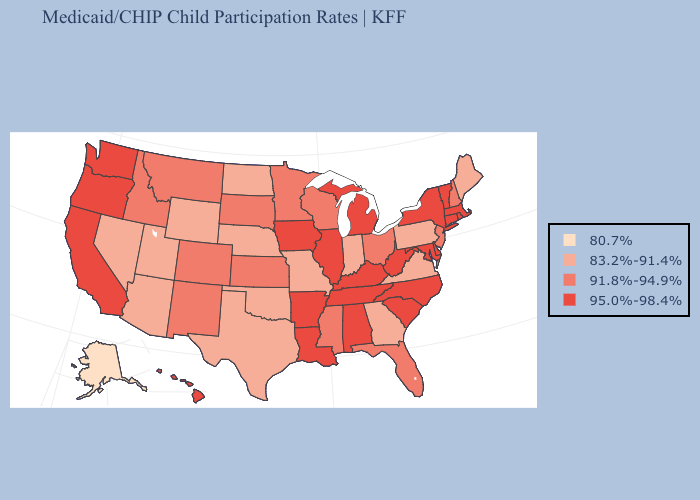What is the lowest value in states that border North Carolina?
Write a very short answer. 83.2%-91.4%. Does Vermont have the lowest value in the Northeast?
Give a very brief answer. No. Does New Mexico have a lower value than Pennsylvania?
Short answer required. No. Does Missouri have a higher value than Alaska?
Keep it brief. Yes. What is the value of Utah?
Be succinct. 83.2%-91.4%. What is the lowest value in states that border Georgia?
Write a very short answer. 91.8%-94.9%. Among the states that border South Carolina , which have the lowest value?
Short answer required. Georgia. What is the lowest value in states that border Delaware?
Write a very short answer. 83.2%-91.4%. Among the states that border Georgia , which have the lowest value?
Quick response, please. Florida. Which states hav the highest value in the MidWest?
Short answer required. Illinois, Iowa, Michigan. Name the states that have a value in the range 95.0%-98.4%?
Answer briefly. Alabama, Arkansas, California, Connecticut, Delaware, Hawaii, Illinois, Iowa, Kentucky, Louisiana, Maryland, Massachusetts, Michigan, New York, North Carolina, Oregon, Rhode Island, South Carolina, Tennessee, Vermont, Washington, West Virginia. What is the lowest value in the MidWest?
Answer briefly. 83.2%-91.4%. What is the value of Missouri?
Write a very short answer. 83.2%-91.4%. What is the value of Indiana?
Quick response, please. 83.2%-91.4%. Among the states that border Georgia , does Florida have the lowest value?
Quick response, please. Yes. 